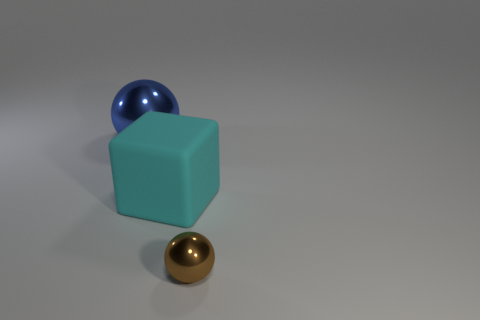Add 1 rubber things. How many objects exist? 4 Subtract all spheres. How many objects are left? 1 Subtract all metal spheres. Subtract all large shiny things. How many objects are left? 0 Add 2 spheres. How many spheres are left? 4 Add 2 large rubber objects. How many large rubber objects exist? 3 Subtract 0 gray balls. How many objects are left? 3 